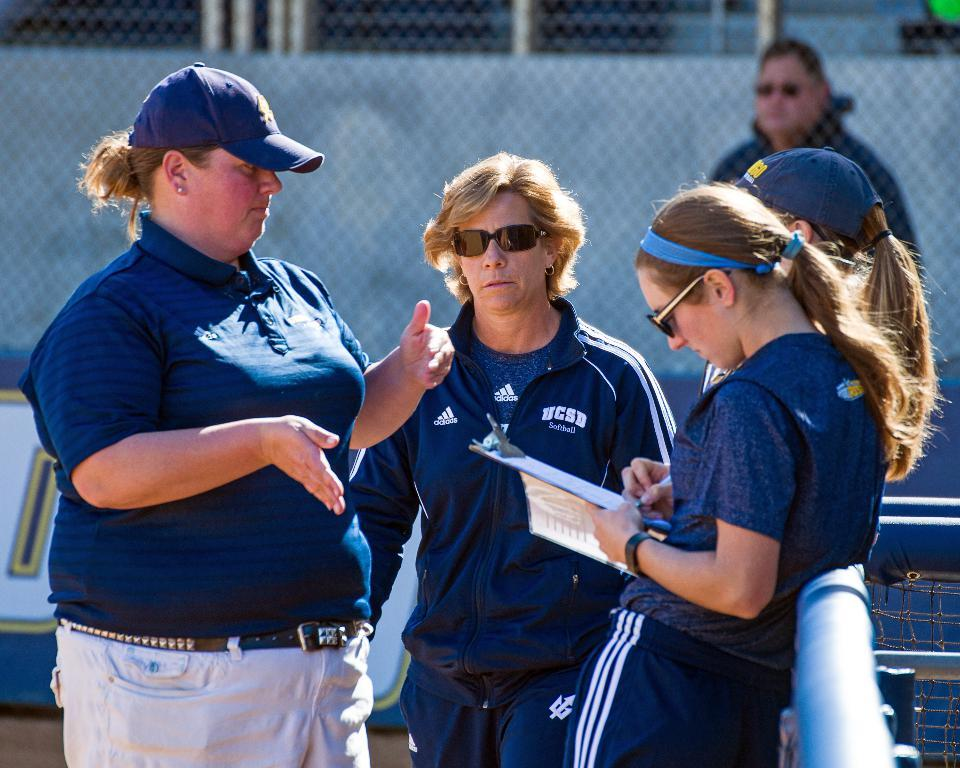Provide a one-sentence caption for the provided image. Women coaches for the UCSD Softball team are talking in a group. 